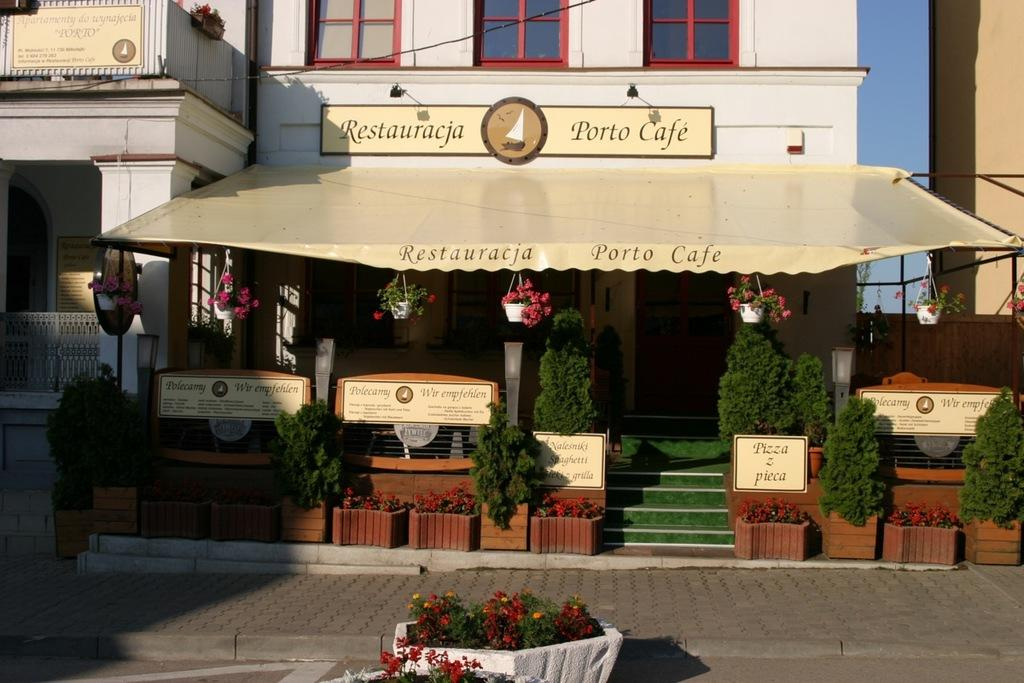What type of structures can be seen in the image? There are buildings in the image. What objects are present that contain plants? There are flower pots in the image. What type of vegetation is visible in the image? There are plants in the image. What architectural feature can be seen in the image? There are steps in the image. What type of signage is present in the image? There are boards in the image. What is written on one of the buildings in the image? Something is written on a building in the image. What can be seen in the background of the image? The sky is visible in the background of the image. Can you tell me how many cars are parked near the flower pots in the image? There is no car present in the image; it only features buildings, flower pots, plants, steps, boards, written text on a building, and the sky in the background. Are there any cacti visible in the image? There is no cactus present in the image; it only features plants, which are not specified as cacti. 